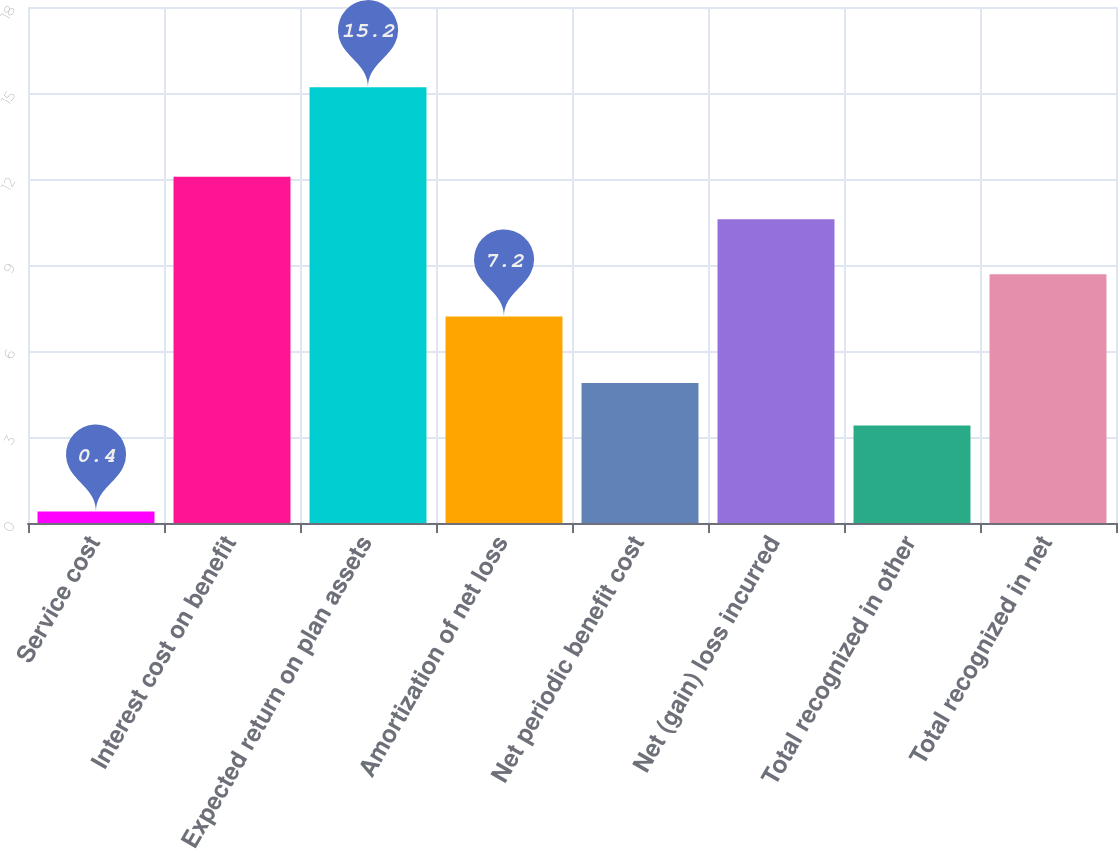<chart> <loc_0><loc_0><loc_500><loc_500><bar_chart><fcel>Service cost<fcel>Interest cost on benefit<fcel>Expected return on plan assets<fcel>Amortization of net loss<fcel>Net periodic benefit cost<fcel>Net (gain) loss incurred<fcel>Total recognized in other<fcel>Total recognized in net<nl><fcel>0.4<fcel>12.08<fcel>15.2<fcel>7.2<fcel>4.88<fcel>10.6<fcel>3.4<fcel>8.68<nl></chart> 